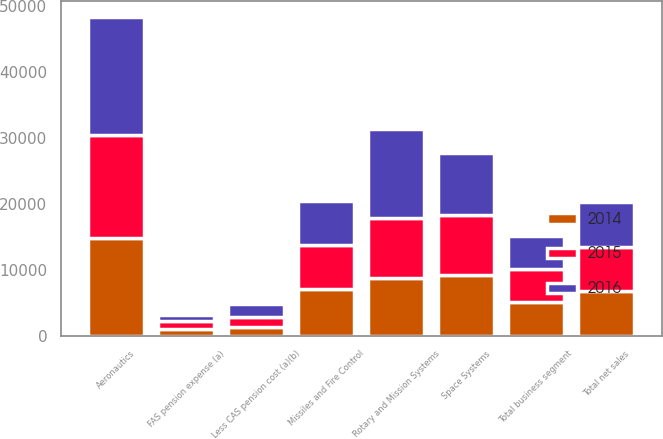Convert chart to OTSL. <chart><loc_0><loc_0><loc_500><loc_500><stacked_bar_chart><ecel><fcel>Aeronautics<fcel>Missiles and Fire Control<fcel>Rotary and Mission Systems<fcel>Space Systems<fcel>Total net sales<fcel>Total business segment<fcel>FAS pension expense (a)<fcel>Less CAS pension cost (a)(b)<nl><fcel>2016<fcel>17769<fcel>6608<fcel>13462<fcel>9409<fcel>6770<fcel>5100<fcel>1019<fcel>1921<nl><fcel>2015<fcel>15570<fcel>6770<fcel>9091<fcel>9105<fcel>6770<fcel>4978<fcel>1127<fcel>1527<nl><fcel>2014<fcel>14920<fcel>7092<fcel>8732<fcel>9202<fcel>6770<fcel>5116<fcel>1099<fcel>1416<nl></chart> 